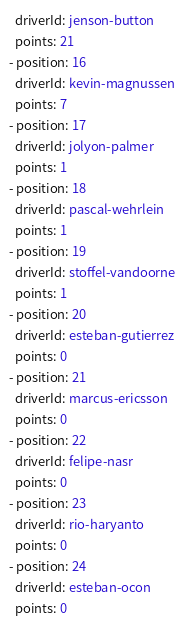Convert code to text. <code><loc_0><loc_0><loc_500><loc_500><_YAML_>  driverId: jenson-button
  points: 21
- position: 16
  driverId: kevin-magnussen
  points: 7
- position: 17
  driverId: jolyon-palmer
  points: 1
- position: 18
  driverId: pascal-wehrlein
  points: 1
- position: 19
  driverId: stoffel-vandoorne
  points: 1
- position: 20
  driverId: esteban-gutierrez
  points: 0
- position: 21
  driverId: marcus-ericsson
  points: 0
- position: 22
  driverId: felipe-nasr
  points: 0
- position: 23
  driverId: rio-haryanto
  points: 0
- position: 24
  driverId: esteban-ocon
  points: 0
</code> 